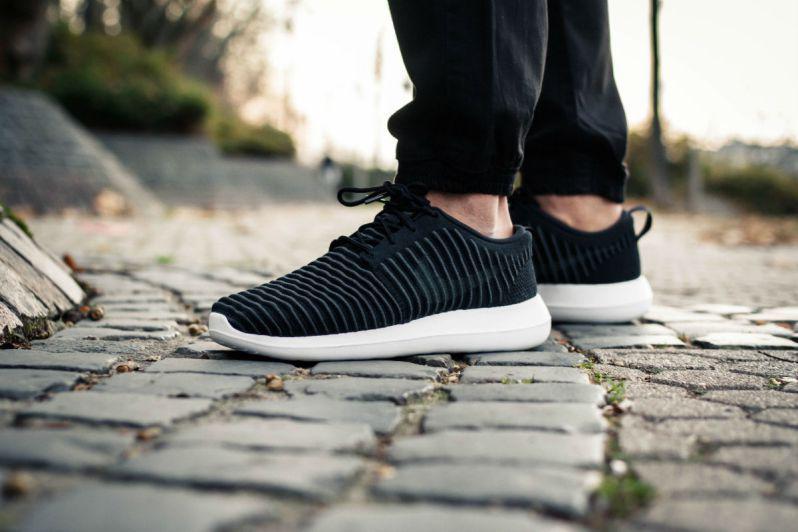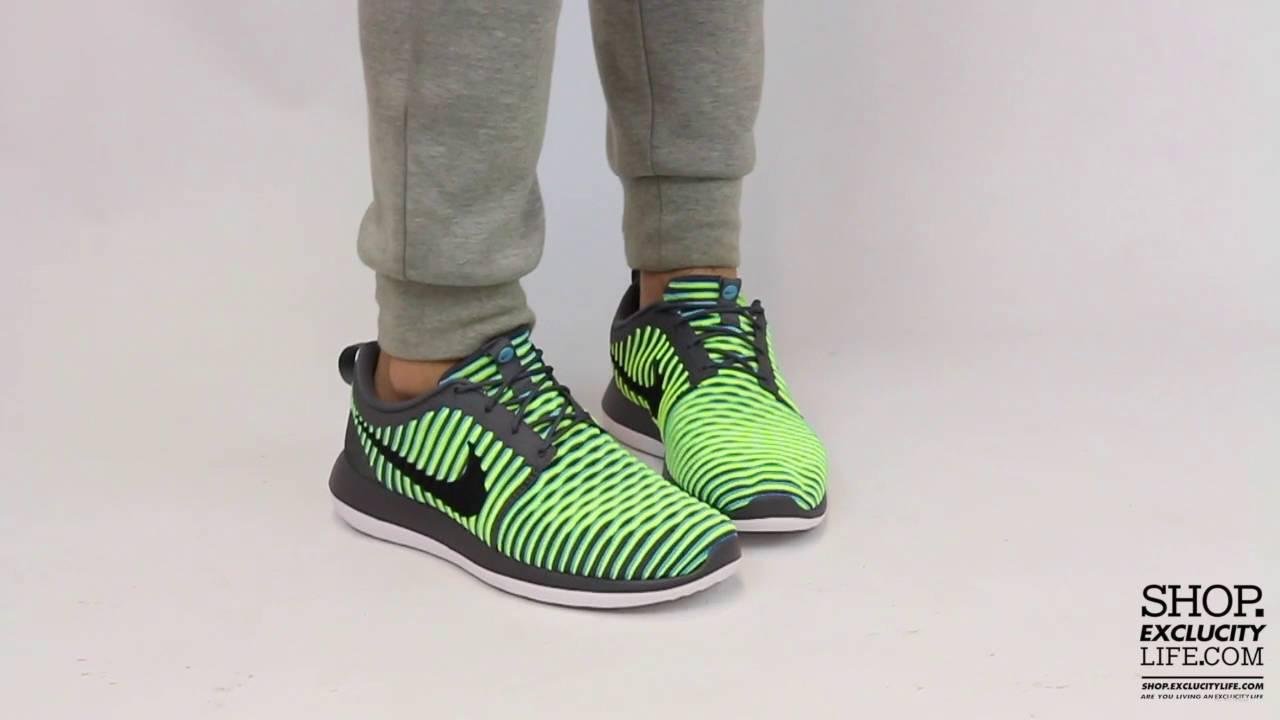The first image is the image on the left, the second image is the image on the right. For the images shown, is this caption "The person in the image on the left is standing with both feet planted firmly a hard surface." true? Answer yes or no. Yes. The first image is the image on the left, the second image is the image on the right. Examine the images to the left and right. Is the description "An image shows a pair of sneaker-wearing feet flat on the ground on an outdoor surface." accurate? Answer yes or no. Yes. 